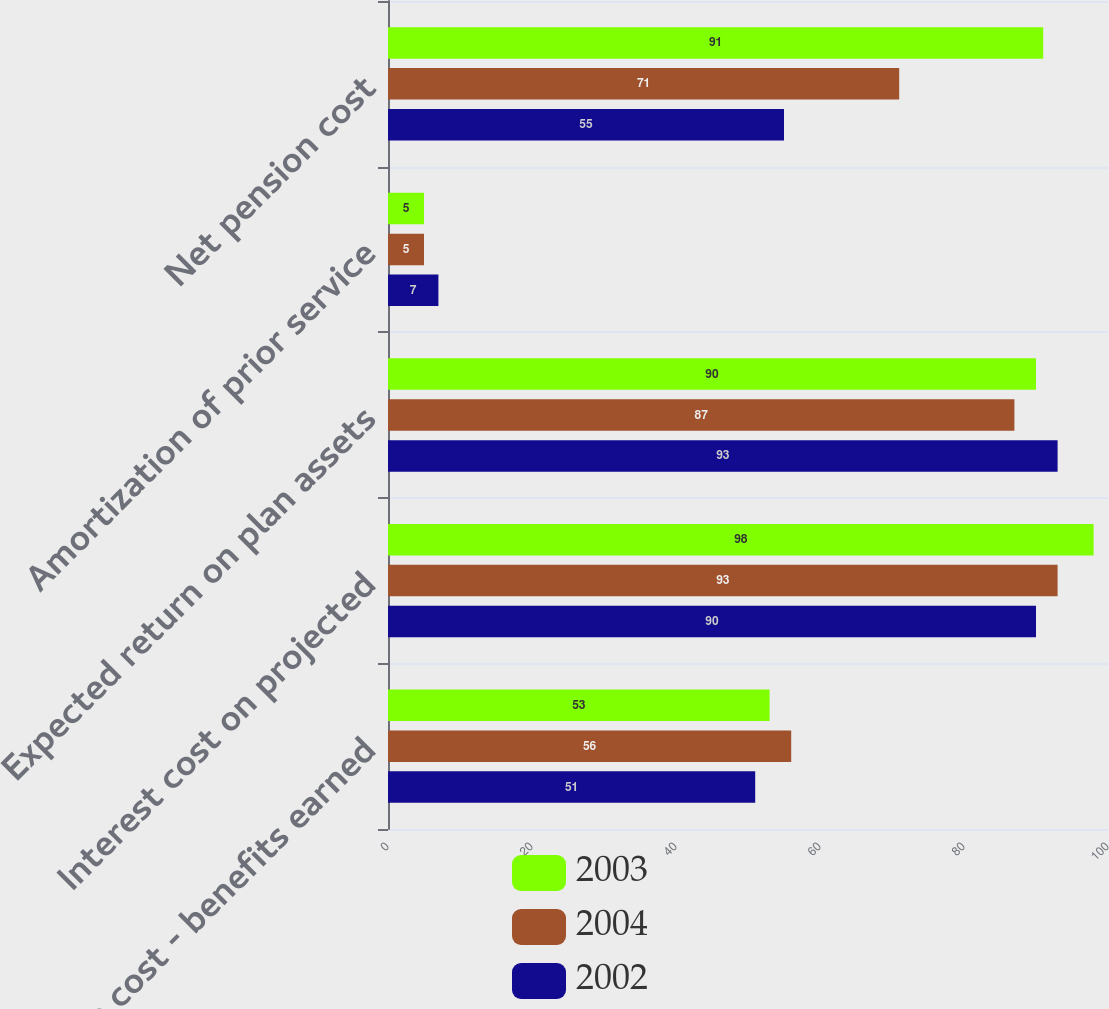Convert chart. <chart><loc_0><loc_0><loc_500><loc_500><stacked_bar_chart><ecel><fcel>Service cost - benefits earned<fcel>Interest cost on projected<fcel>Expected return on plan assets<fcel>Amortization of prior service<fcel>Net pension cost<nl><fcel>2003<fcel>53<fcel>98<fcel>90<fcel>5<fcel>91<nl><fcel>2004<fcel>56<fcel>93<fcel>87<fcel>5<fcel>71<nl><fcel>2002<fcel>51<fcel>90<fcel>93<fcel>7<fcel>55<nl></chart> 